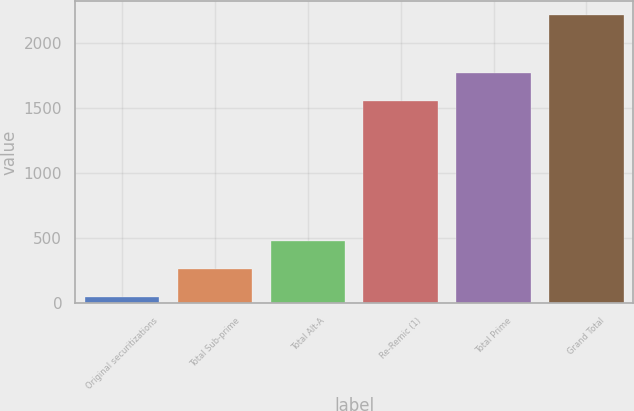Convert chart. <chart><loc_0><loc_0><loc_500><loc_500><bar_chart><fcel>Original securitizations<fcel>Total Sub-prime<fcel>Total Alt-A<fcel>Re-Remic (1)<fcel>Total Prime<fcel>Grand Total<nl><fcel>47<fcel>263.5<fcel>480<fcel>1553<fcel>1769.5<fcel>2212<nl></chart> 